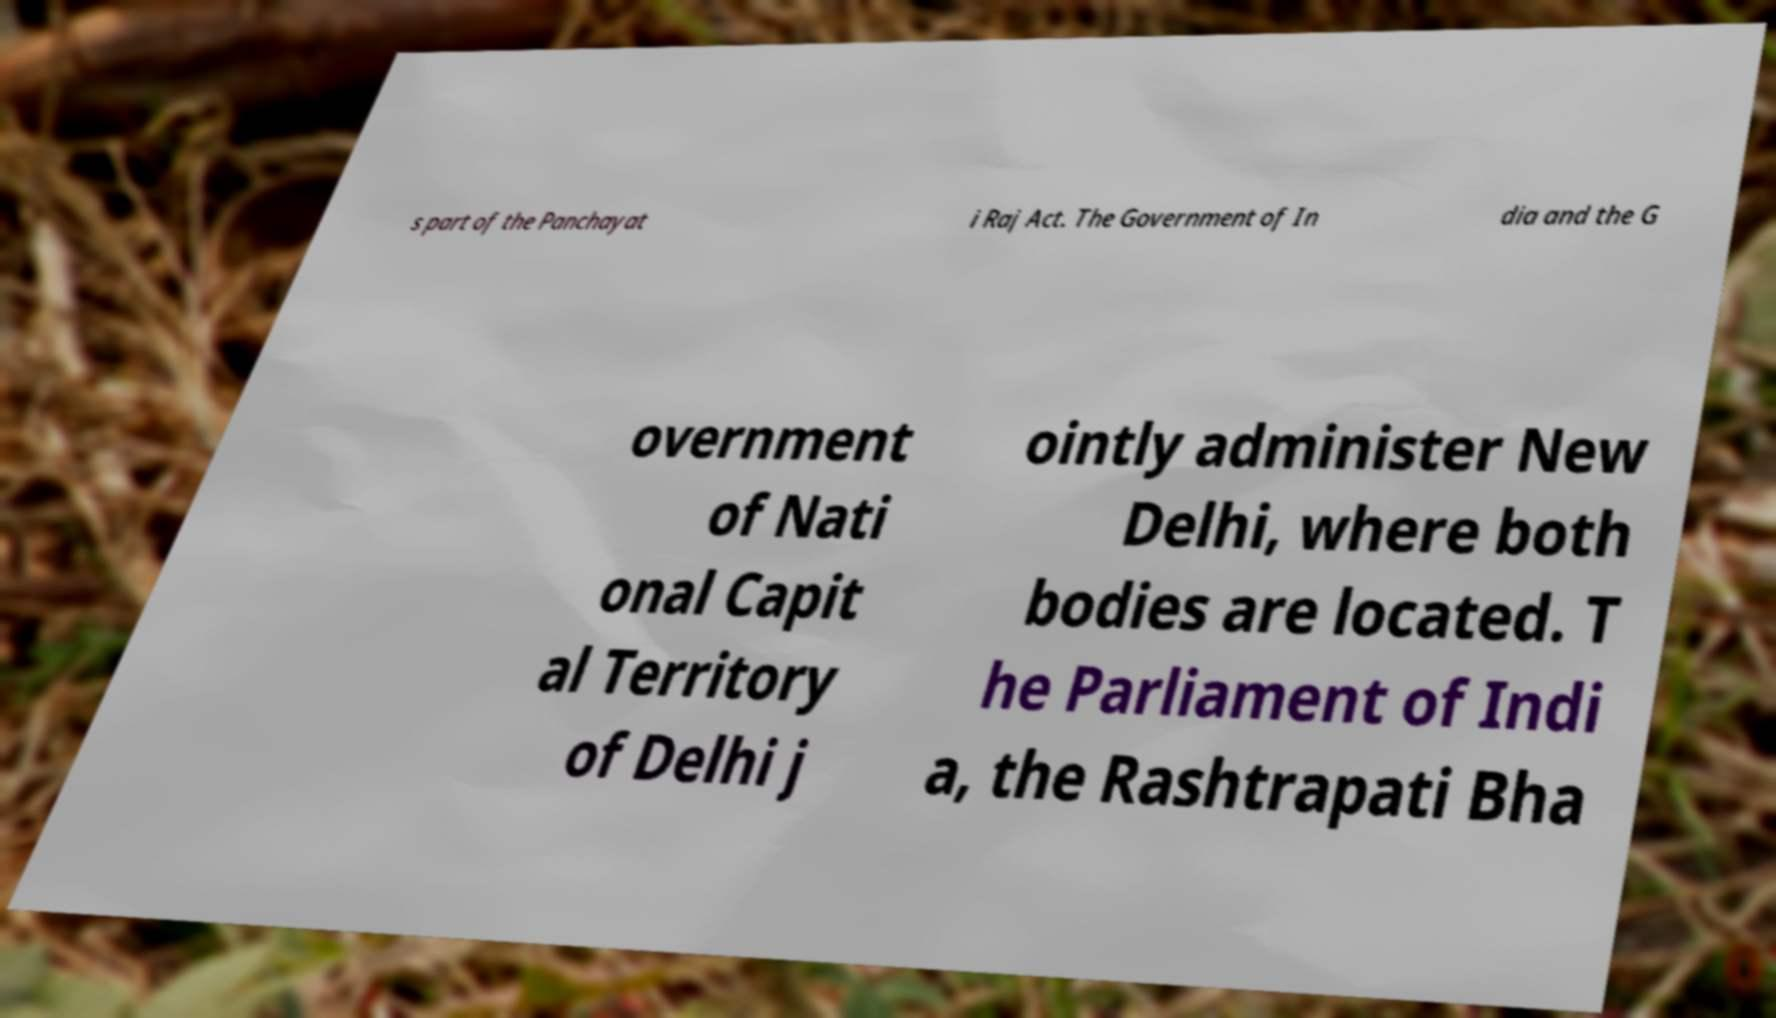Please read and relay the text visible in this image. What does it say? s part of the Panchayat i Raj Act. The Government of In dia and the G overnment of Nati onal Capit al Territory of Delhi j ointly administer New Delhi, where both bodies are located. T he Parliament of Indi a, the Rashtrapati Bha 